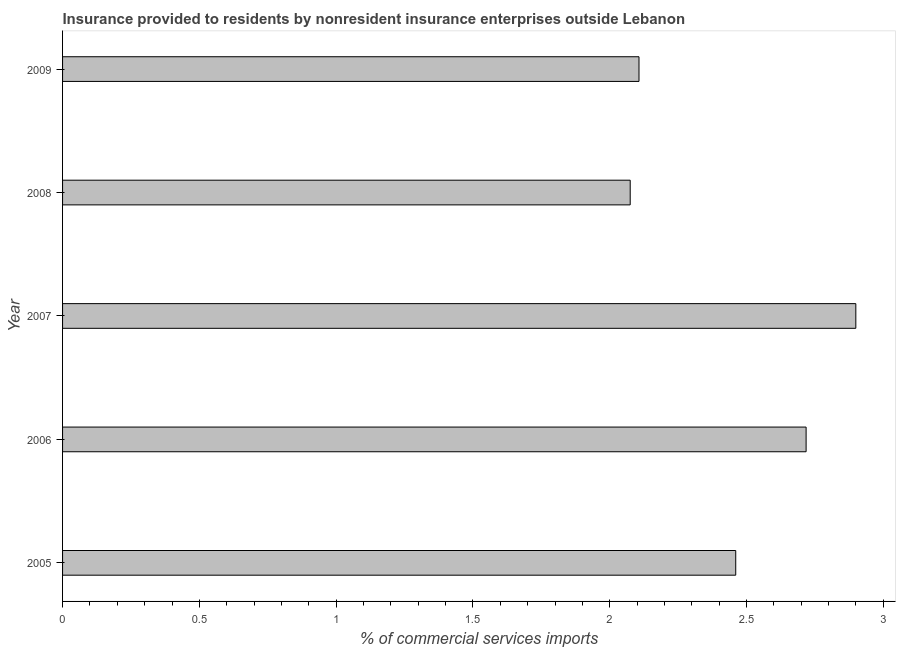Does the graph contain any zero values?
Provide a short and direct response. No. What is the title of the graph?
Make the answer very short. Insurance provided to residents by nonresident insurance enterprises outside Lebanon. What is the label or title of the X-axis?
Provide a succinct answer. % of commercial services imports. What is the insurance provided by non-residents in 2009?
Give a very brief answer. 2.11. Across all years, what is the maximum insurance provided by non-residents?
Offer a terse response. 2.9. Across all years, what is the minimum insurance provided by non-residents?
Ensure brevity in your answer.  2.07. What is the sum of the insurance provided by non-residents?
Ensure brevity in your answer.  12.26. What is the difference between the insurance provided by non-residents in 2008 and 2009?
Provide a succinct answer. -0.03. What is the average insurance provided by non-residents per year?
Offer a terse response. 2.45. What is the median insurance provided by non-residents?
Make the answer very short. 2.46. In how many years, is the insurance provided by non-residents greater than 1.3 %?
Offer a terse response. 5. What is the ratio of the insurance provided by non-residents in 2007 to that in 2009?
Your answer should be compact. 1.38. What is the difference between the highest and the second highest insurance provided by non-residents?
Offer a very short reply. 0.18. Is the sum of the insurance provided by non-residents in 2005 and 2007 greater than the maximum insurance provided by non-residents across all years?
Provide a succinct answer. Yes. What is the difference between the highest and the lowest insurance provided by non-residents?
Your response must be concise. 0.82. Are all the bars in the graph horizontal?
Provide a succinct answer. Yes. How many years are there in the graph?
Offer a very short reply. 5. Are the values on the major ticks of X-axis written in scientific E-notation?
Ensure brevity in your answer.  No. What is the % of commercial services imports in 2005?
Your answer should be very brief. 2.46. What is the % of commercial services imports of 2006?
Offer a terse response. 2.72. What is the % of commercial services imports of 2007?
Your response must be concise. 2.9. What is the % of commercial services imports of 2008?
Offer a terse response. 2.07. What is the % of commercial services imports in 2009?
Your answer should be compact. 2.11. What is the difference between the % of commercial services imports in 2005 and 2006?
Your answer should be compact. -0.26. What is the difference between the % of commercial services imports in 2005 and 2007?
Provide a succinct answer. -0.44. What is the difference between the % of commercial services imports in 2005 and 2008?
Offer a very short reply. 0.39. What is the difference between the % of commercial services imports in 2005 and 2009?
Your answer should be compact. 0.35. What is the difference between the % of commercial services imports in 2006 and 2007?
Provide a short and direct response. -0.18. What is the difference between the % of commercial services imports in 2006 and 2008?
Your response must be concise. 0.64. What is the difference between the % of commercial services imports in 2006 and 2009?
Keep it short and to the point. 0.61. What is the difference between the % of commercial services imports in 2007 and 2008?
Your response must be concise. 0.82. What is the difference between the % of commercial services imports in 2007 and 2009?
Make the answer very short. 0.79. What is the difference between the % of commercial services imports in 2008 and 2009?
Your answer should be compact. -0.03. What is the ratio of the % of commercial services imports in 2005 to that in 2006?
Your answer should be compact. 0.91. What is the ratio of the % of commercial services imports in 2005 to that in 2007?
Provide a succinct answer. 0.85. What is the ratio of the % of commercial services imports in 2005 to that in 2008?
Give a very brief answer. 1.19. What is the ratio of the % of commercial services imports in 2005 to that in 2009?
Your answer should be very brief. 1.17. What is the ratio of the % of commercial services imports in 2006 to that in 2007?
Offer a terse response. 0.94. What is the ratio of the % of commercial services imports in 2006 to that in 2008?
Keep it short and to the point. 1.31. What is the ratio of the % of commercial services imports in 2006 to that in 2009?
Provide a short and direct response. 1.29. What is the ratio of the % of commercial services imports in 2007 to that in 2008?
Your answer should be compact. 1.4. What is the ratio of the % of commercial services imports in 2007 to that in 2009?
Provide a short and direct response. 1.38. What is the ratio of the % of commercial services imports in 2008 to that in 2009?
Ensure brevity in your answer.  0.98. 